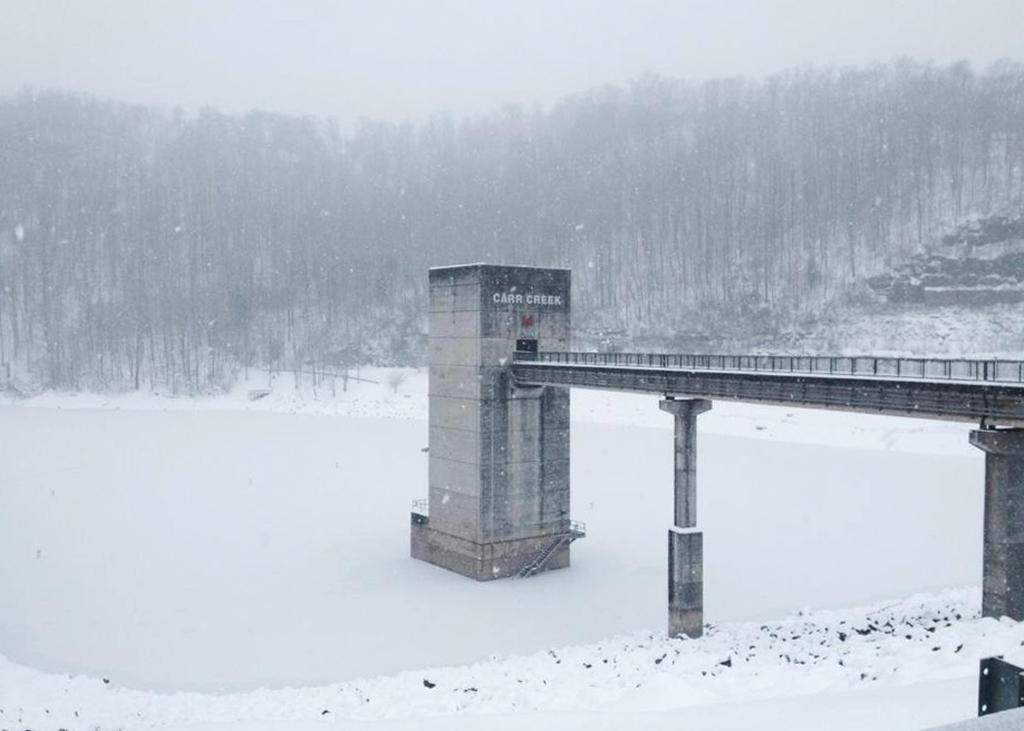Can you describe this image briefly? This image consists of a bridge along with pillars. At the bottom, there is snow. In the background, there are trees. At the top, there is sky. 